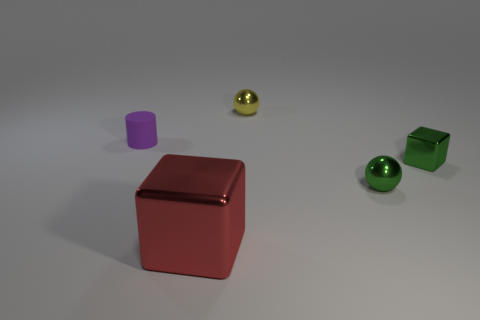How many other things are the same size as the purple matte cylinder?
Provide a succinct answer. 3. Does the rubber thing have the same color as the large cube?
Offer a very short reply. No. How many purple cylinders are behind the metal cube behind the cube that is on the left side of the tiny green metal sphere?
Keep it short and to the point. 1. The tiny thing to the left of the cube that is on the left side of the yellow thing is made of what material?
Keep it short and to the point. Rubber. Is there another green thing of the same shape as the large metal thing?
Provide a succinct answer. Yes. What is the color of the block that is the same size as the purple rubber thing?
Keep it short and to the point. Green. What number of objects are tiny things that are to the left of the big object or metallic cubes that are to the right of the red thing?
Offer a terse response. 2. What number of things are small yellow shiny things or big red metallic cubes?
Provide a short and direct response. 2. What size is the object that is both on the left side of the yellow ball and in front of the small cylinder?
Provide a short and direct response. Large. What number of yellow blocks have the same material as the tiny yellow object?
Offer a terse response. 0. 